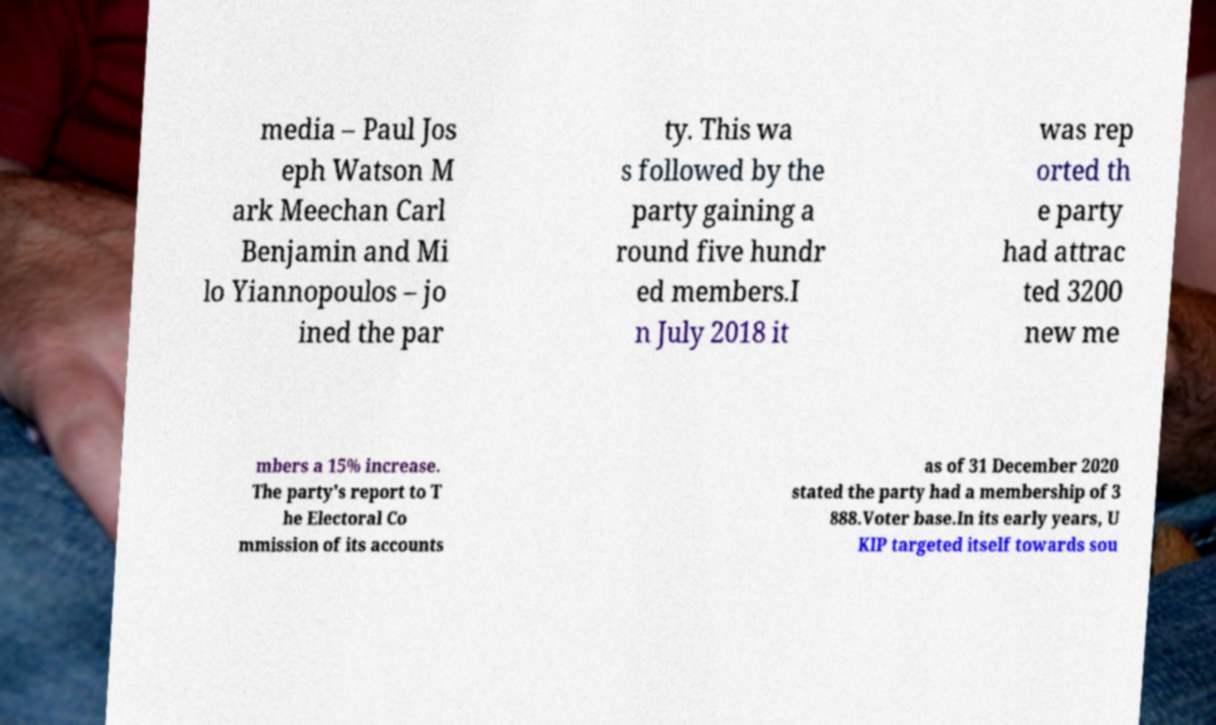Can you read and provide the text displayed in the image?This photo seems to have some interesting text. Can you extract and type it out for me? media – Paul Jos eph Watson M ark Meechan Carl Benjamin and Mi lo Yiannopoulos – jo ined the par ty. This wa s followed by the party gaining a round five hundr ed members.I n July 2018 it was rep orted th e party had attrac ted 3200 new me mbers a 15% increase. The party's report to T he Electoral Co mmission of its accounts as of 31 December 2020 stated the party had a membership of 3 888.Voter base.In its early years, U KIP targeted itself towards sou 